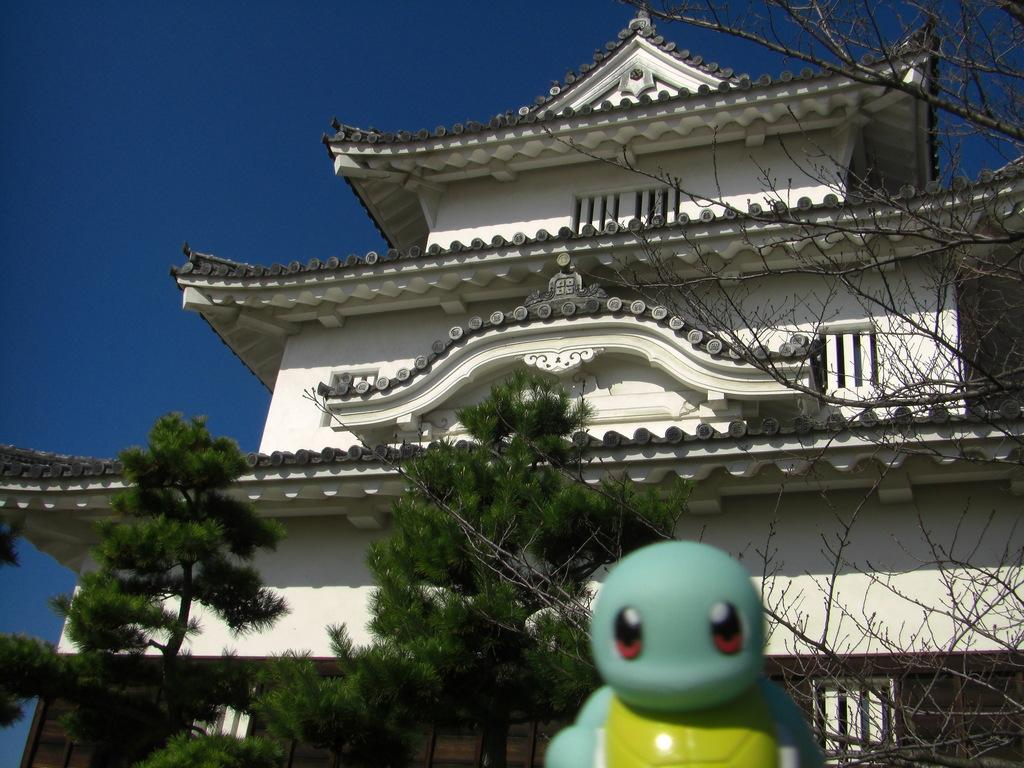What object is located at the bottom of the image? There is a toy at the bottom of the image. What can be seen in the background of the image? There is a building and trees in the background of the image. What is visible at the top of the image? The sky is visible at the top of the image. What type of music is the dad playing in the image? There is no dad or music present in the image. 